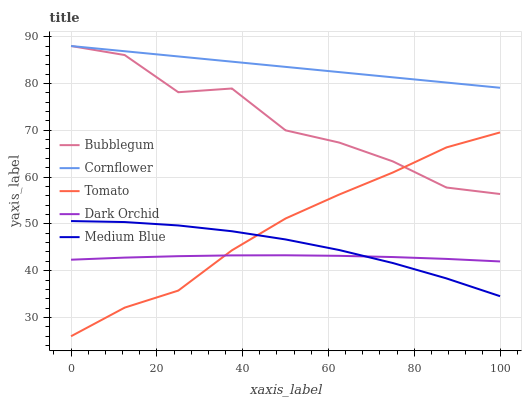Does Dark Orchid have the minimum area under the curve?
Answer yes or no. Yes. Does Cornflower have the maximum area under the curve?
Answer yes or no. Yes. Does Medium Blue have the minimum area under the curve?
Answer yes or no. No. Does Medium Blue have the maximum area under the curve?
Answer yes or no. No. Is Cornflower the smoothest?
Answer yes or no. Yes. Is Bubblegum the roughest?
Answer yes or no. Yes. Is Medium Blue the smoothest?
Answer yes or no. No. Is Medium Blue the roughest?
Answer yes or no. No. Does Tomato have the lowest value?
Answer yes or no. Yes. Does Medium Blue have the lowest value?
Answer yes or no. No. Does Bubblegum have the highest value?
Answer yes or no. Yes. Does Medium Blue have the highest value?
Answer yes or no. No. Is Tomato less than Cornflower?
Answer yes or no. Yes. Is Bubblegum greater than Medium Blue?
Answer yes or no. Yes. Does Tomato intersect Medium Blue?
Answer yes or no. Yes. Is Tomato less than Medium Blue?
Answer yes or no. No. Is Tomato greater than Medium Blue?
Answer yes or no. No. Does Tomato intersect Cornflower?
Answer yes or no. No. 